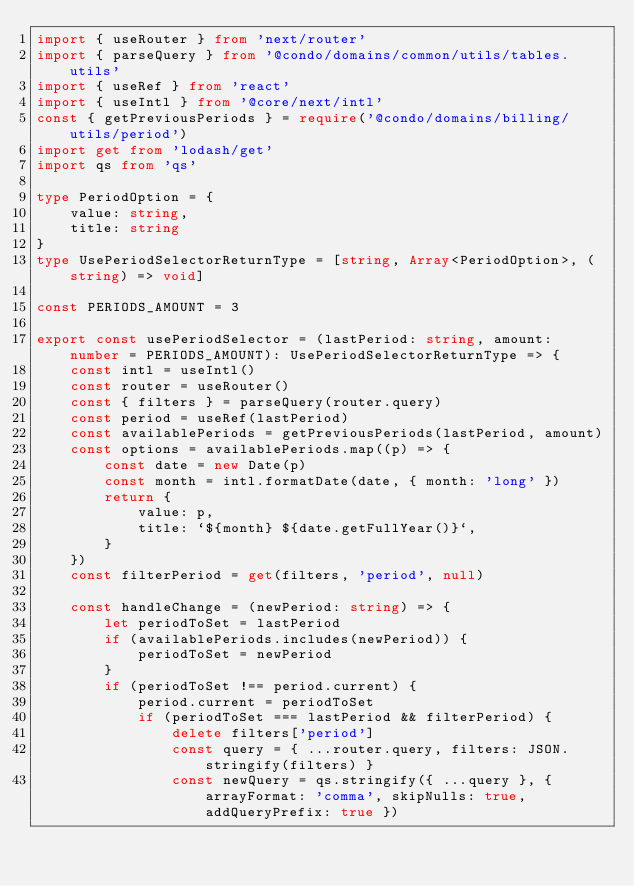<code> <loc_0><loc_0><loc_500><loc_500><_TypeScript_>import { useRouter } from 'next/router'
import { parseQuery } from '@condo/domains/common/utils/tables.utils'
import { useRef } from 'react'
import { useIntl } from '@core/next/intl'
const { getPreviousPeriods } = require('@condo/domains/billing/utils/period')
import get from 'lodash/get'
import qs from 'qs'

type PeriodOption = {
    value: string,
    title: string
}
type UsePeriodSelectorReturnType = [string, Array<PeriodOption>, (string) => void]

const PERIODS_AMOUNT = 3

export const usePeriodSelector = (lastPeriod: string, amount: number = PERIODS_AMOUNT): UsePeriodSelectorReturnType => {
    const intl = useIntl()
    const router = useRouter()
    const { filters } = parseQuery(router.query)
    const period = useRef(lastPeriod)
    const availablePeriods = getPreviousPeriods(lastPeriod, amount)
    const options = availablePeriods.map((p) => {
        const date = new Date(p)
        const month = intl.formatDate(date, { month: 'long' })
        return {
            value: p,
            title: `${month} ${date.getFullYear()}`,
        }
    })
    const filterPeriod = get(filters, 'period', null)

    const handleChange = (newPeriod: string) => {
        let periodToSet = lastPeriod
        if (availablePeriods.includes(newPeriod)) {
            periodToSet = newPeriod
        }
        if (periodToSet !== period.current) {
            period.current = periodToSet
            if (periodToSet === lastPeriod && filterPeriod) {
                delete filters['period']
                const query = { ...router.query, filters: JSON.stringify(filters) }
                const newQuery = qs.stringify({ ...query }, { arrayFormat: 'comma', skipNulls: true, addQueryPrefix: true })</code> 